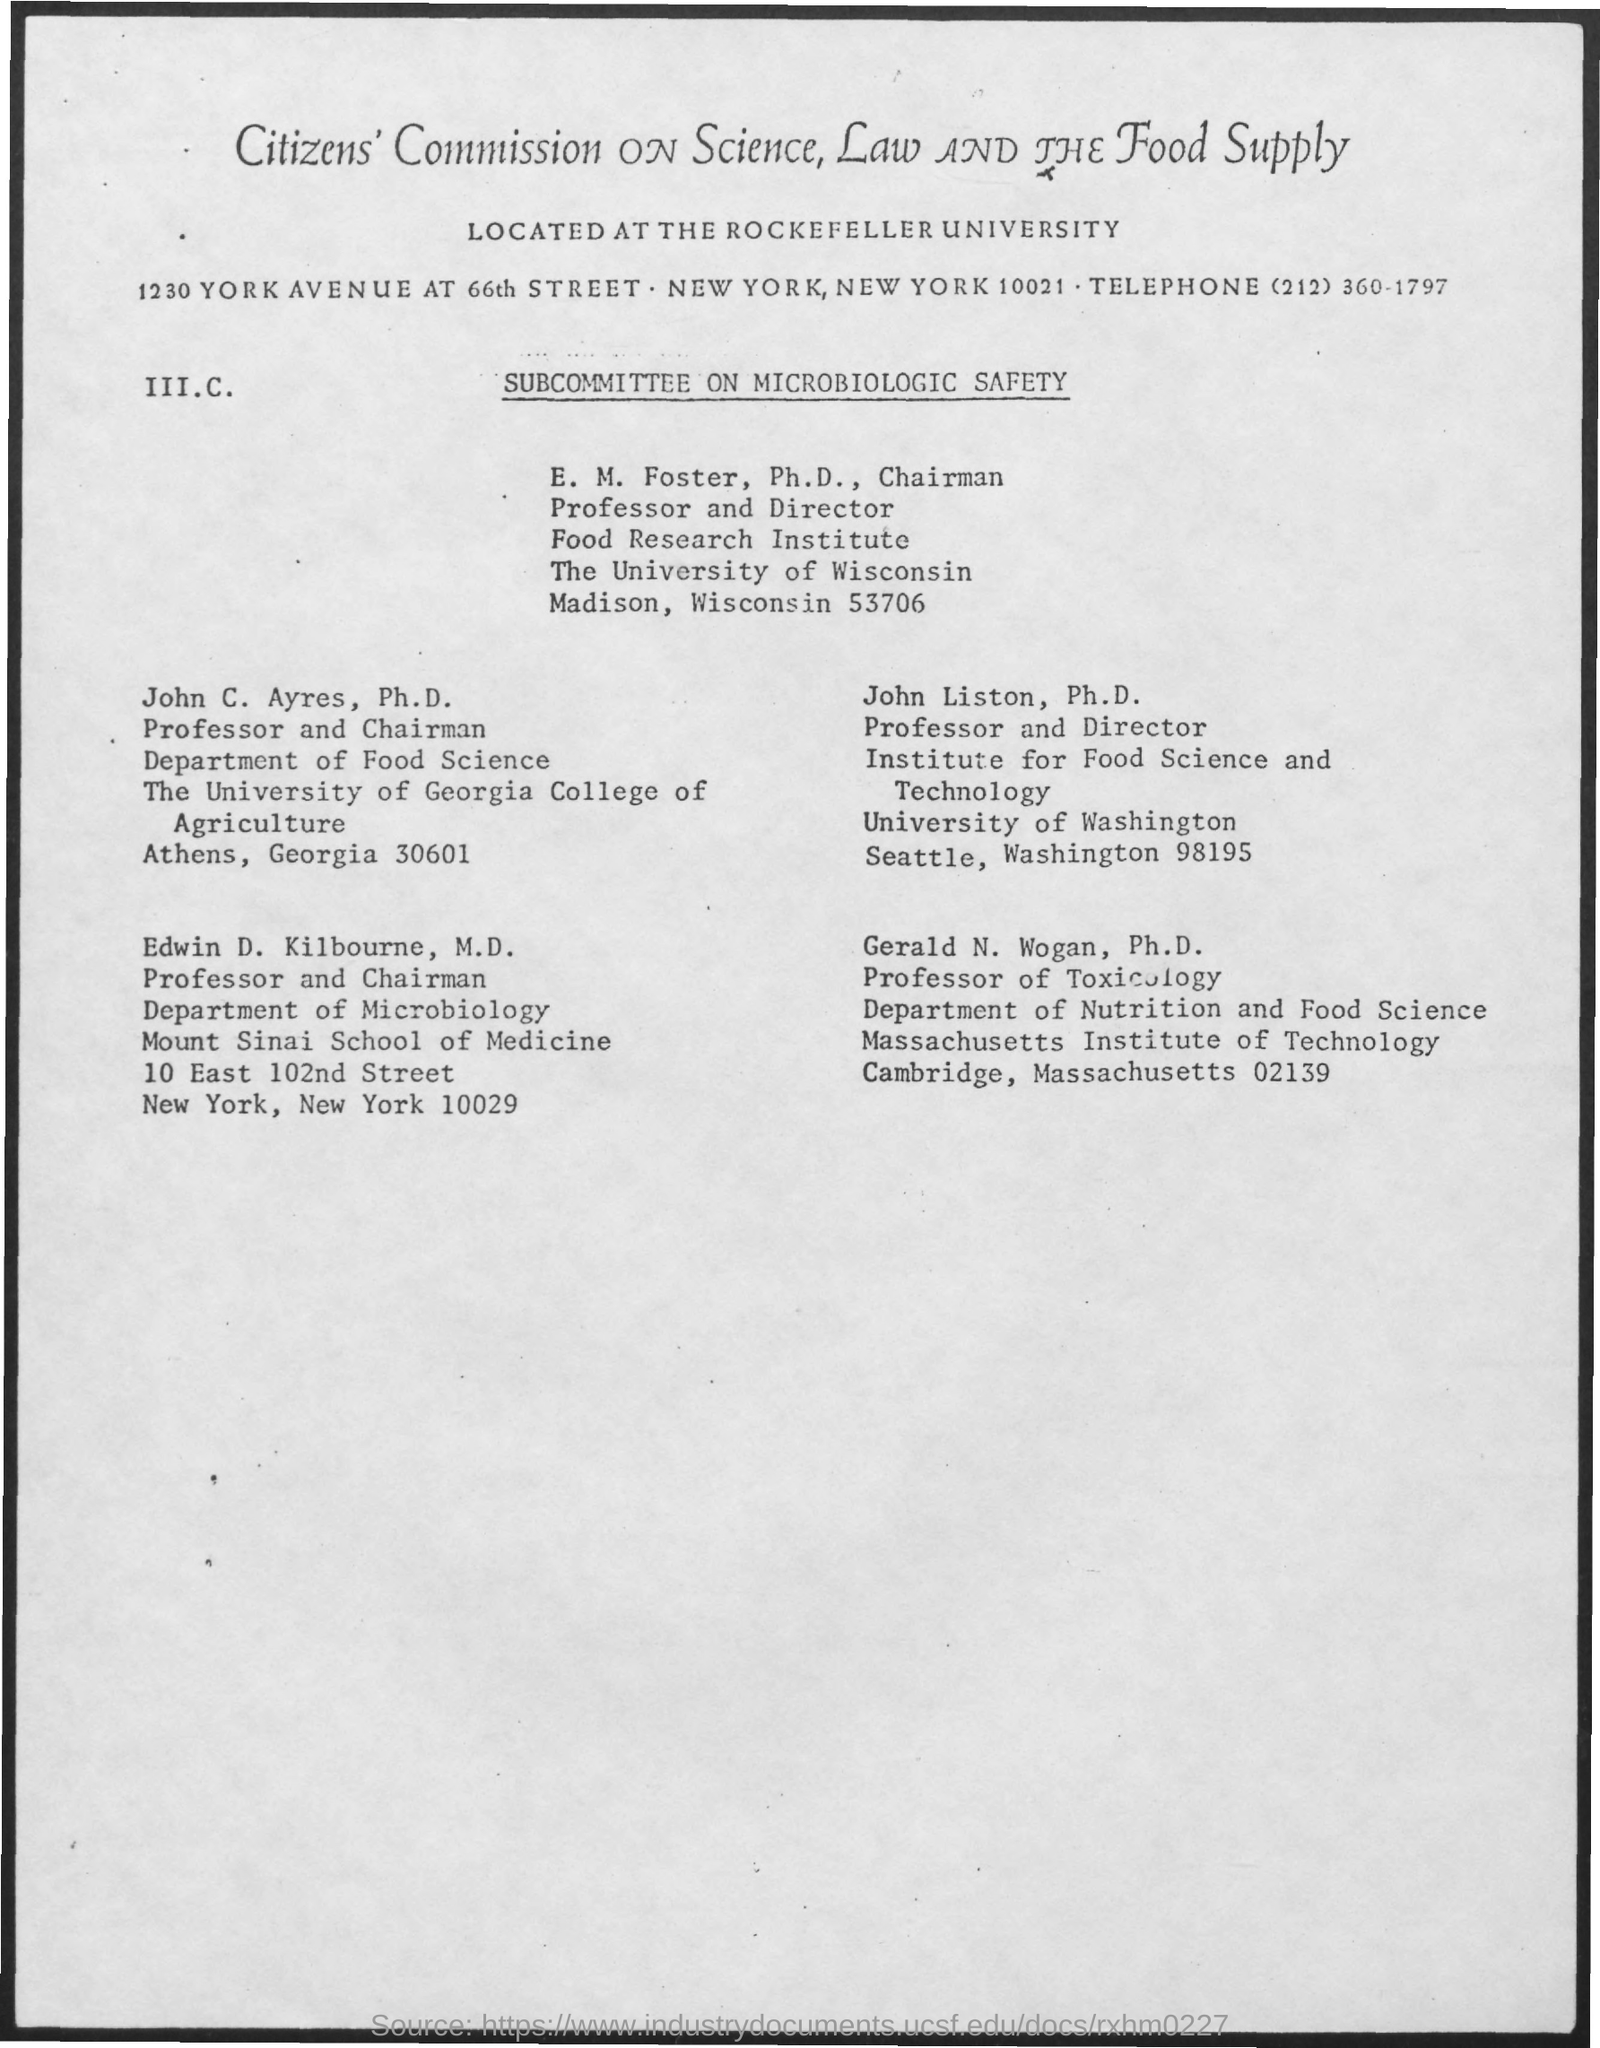What is the telephone number?
Keep it short and to the point. (212) 360-1797. 